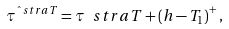Convert formula to latex. <formula><loc_0><loc_0><loc_500><loc_500>\tau ^ { \hat { \ } s t r a T } = \tau ^ { \ } s t r a T + \left ( h - T _ { 1 } \right ) ^ { + } ,</formula> 